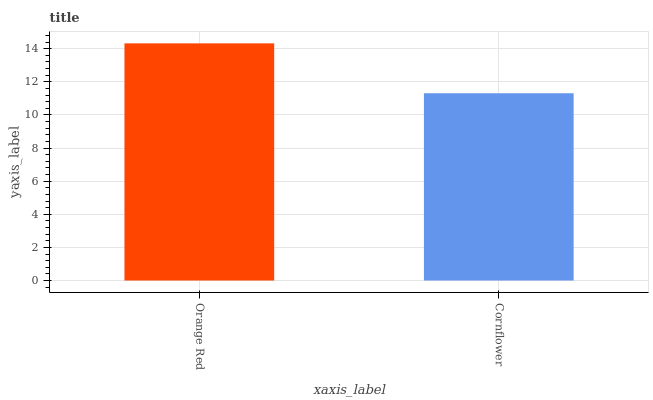Is Cornflower the minimum?
Answer yes or no. Yes. Is Orange Red the maximum?
Answer yes or no. Yes. Is Cornflower the maximum?
Answer yes or no. No. Is Orange Red greater than Cornflower?
Answer yes or no. Yes. Is Cornflower less than Orange Red?
Answer yes or no. Yes. Is Cornflower greater than Orange Red?
Answer yes or no. No. Is Orange Red less than Cornflower?
Answer yes or no. No. Is Orange Red the high median?
Answer yes or no. Yes. Is Cornflower the low median?
Answer yes or no. Yes. Is Cornflower the high median?
Answer yes or no. No. Is Orange Red the low median?
Answer yes or no. No. 